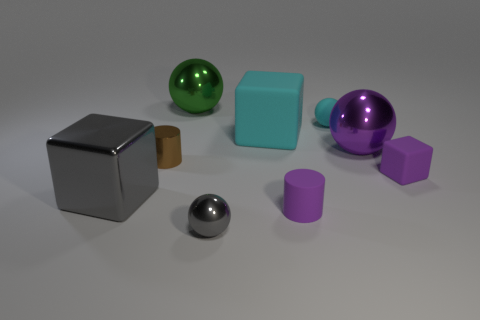Is there anything else that has the same color as the metallic cylinder?
Provide a succinct answer. No. Is the number of large balls less than the number of tiny blue matte cylinders?
Provide a succinct answer. No. What material is the big ball that is on the left side of the small ball that is behind the gray metal block?
Provide a short and direct response. Metal. Is the size of the matte cylinder the same as the metallic cylinder?
Your answer should be compact. Yes. How many objects are either big rubber cubes or gray objects?
Keep it short and to the point. 3. There is a purple object that is behind the matte cylinder and to the left of the tiny block; what size is it?
Your response must be concise. Large. Are there fewer green objects that are in front of the purple matte cylinder than gray cubes?
Your answer should be compact. Yes. What shape is the large green object that is the same material as the gray sphere?
Ensure brevity in your answer.  Sphere. There is a small purple thing behind the small rubber cylinder; is it the same shape as the gray object that is behind the small gray shiny sphere?
Provide a short and direct response. Yes. Are there fewer shiny objects that are left of the tiny brown thing than small things that are behind the tiny cyan rubber sphere?
Your answer should be very brief. No. 